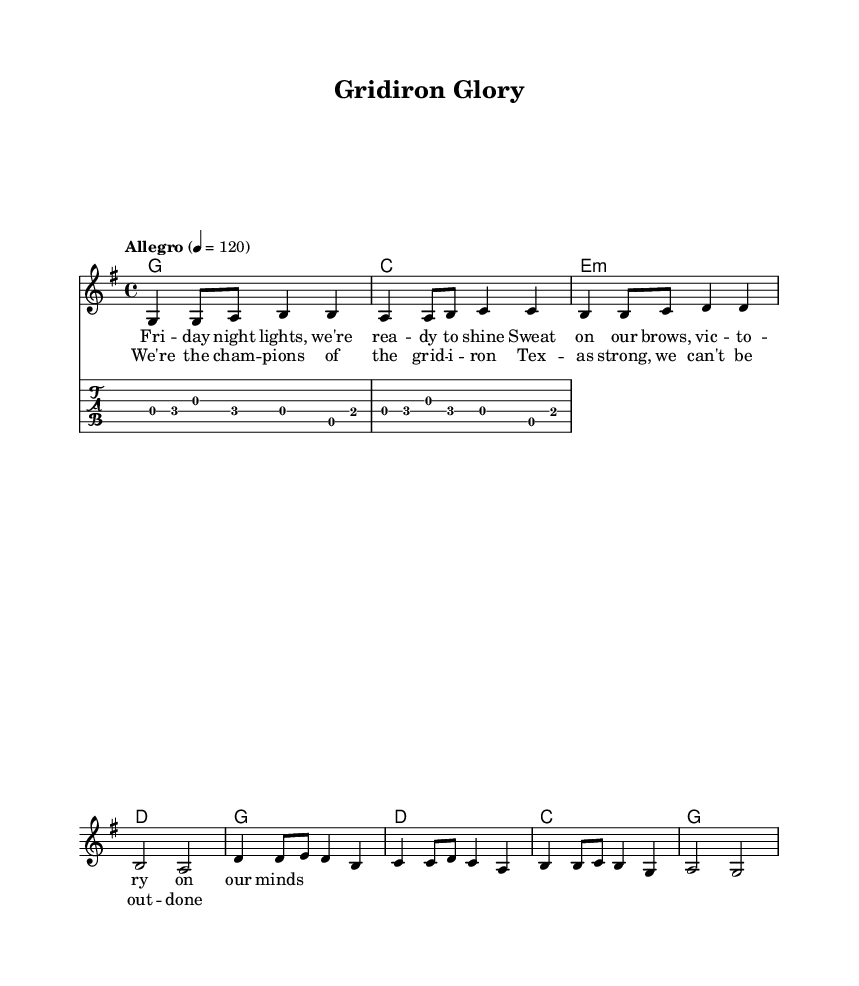What is the key signature of this music? The key signature is G major, which has one sharp (F#). This can be identified by looking at the key signature located at the beginning of the staff in the music sheet.
Answer: G major What is the time signature of this music? The time signature is 4/4, indicating there are four beats in each measure and a quarter note receives one beat. This is visible on the left side of the first measure.
Answer: 4/4 What is the tempo marking? The tempo marking is "Allegro," which indicates the piece should be played at a quick pace. The specific BPM given is 120, showing the beats per minute for clarity in performance.
Answer: Allegro How many measures are in the verse? There are four measures in the verse, which can be assessed by counting the measure boundaries within the verse section of the sheet music. Each measure is clearly marked.
Answer: 4 What are the chord names in the chorus section? The chord names in the chorus section are G, D, C, and G. These can be determined by reading the chord symbols written above the corresponding staff in the chorus part of the music.
Answer: G, D, C, G What type of guitar technique is used in the guitar riff? The guitar riff primarily consists of alternate picking, which is common in country rock for achieving a smooth and rhythmic sound. This is informed by the note patterns and the style typical of the genre.
Answer: Alternate picking What is the main thematic focus of the lyrics? The main thematic focus of the lyrics is victory and strength in football, reflecting the motivational spirit of a pre-game atmosphere. This can be determined by analyzing the lyrics presented in the verse and chorus, which emphasize readiness and championship.
Answer: Victory and strength 